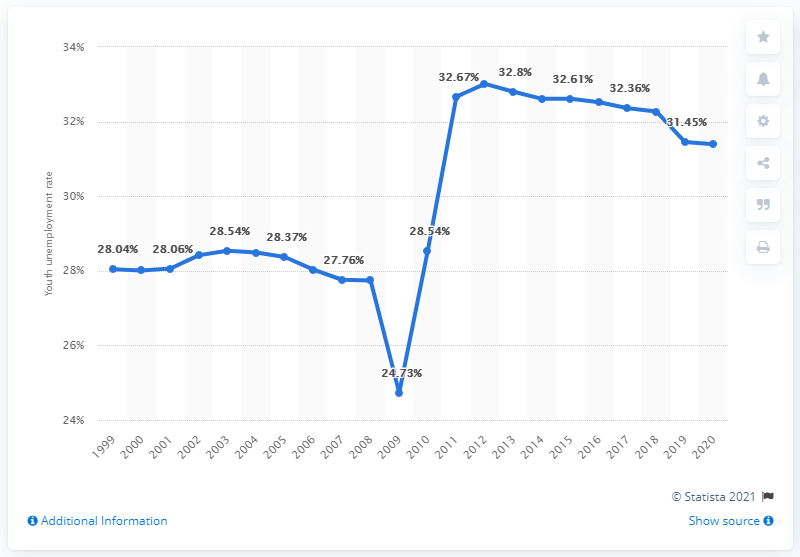Specify some key components in this picture. In 2020, the youth unemployment rate in Sudan was 31.39%. 